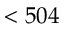<formula> <loc_0><loc_0><loc_500><loc_500>< 5 0 4</formula> 